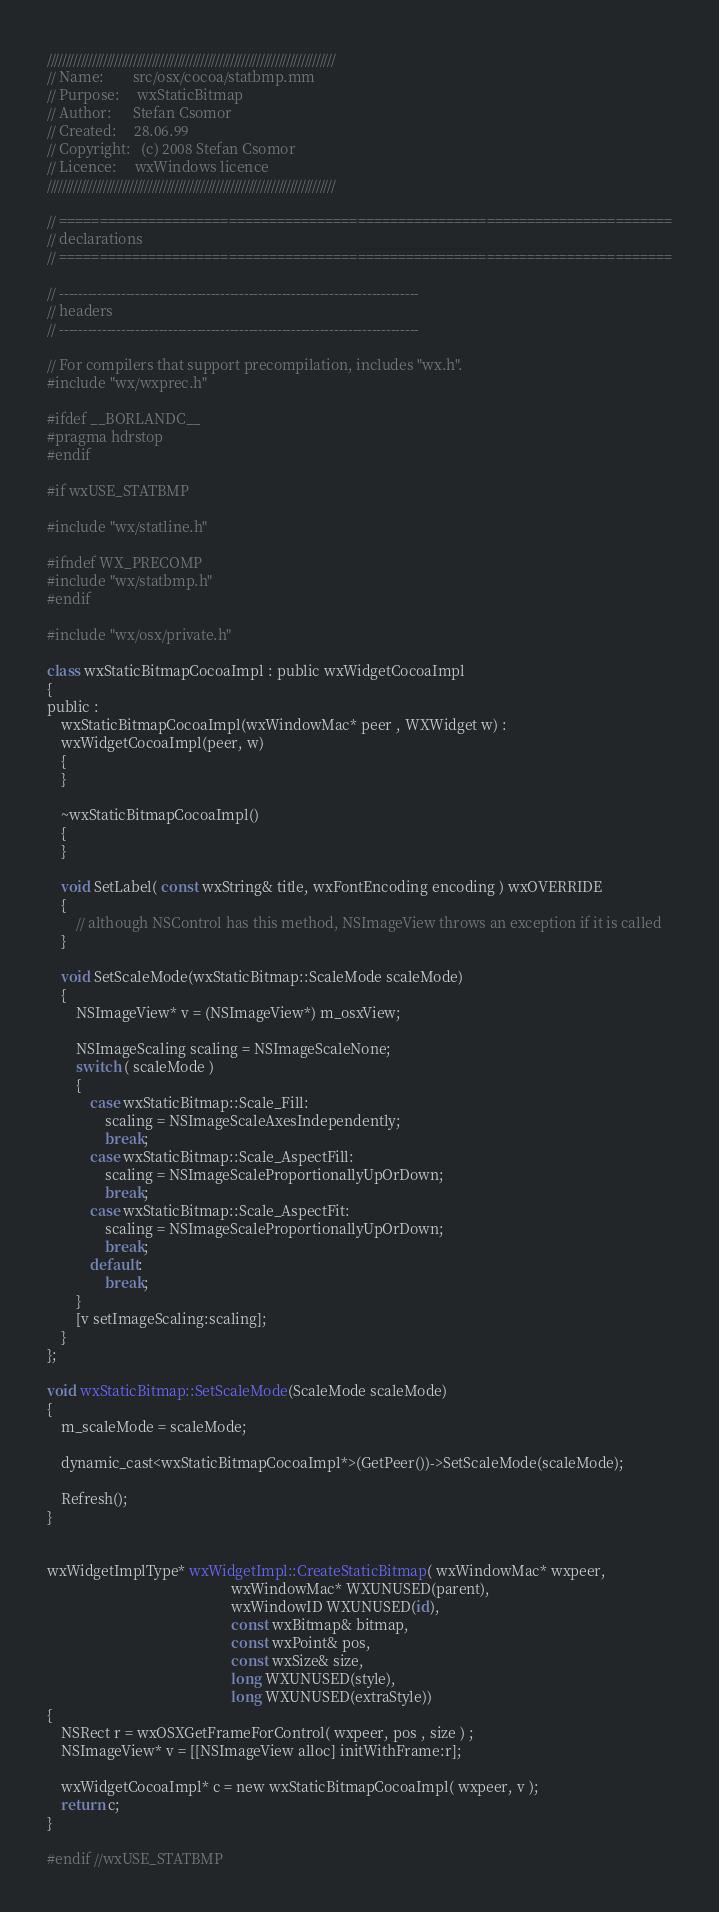Convert code to text. <code><loc_0><loc_0><loc_500><loc_500><_ObjectiveC_>/////////////////////////////////////////////////////////////////////////////
// Name:        src/osx/cocoa/statbmp.mm
// Purpose:     wxStaticBitmap
// Author:      Stefan Csomor
// Created:     28.06.99
// Copyright:   (c) 2008 Stefan Csomor
// Licence:     wxWindows licence
/////////////////////////////////////////////////////////////////////////////

// ============================================================================
// declarations
// ============================================================================

// ----------------------------------------------------------------------------
// headers
// ----------------------------------------------------------------------------

// For compilers that support precompilation, includes "wx.h".
#include "wx/wxprec.h"

#ifdef __BORLANDC__
#pragma hdrstop
#endif

#if wxUSE_STATBMP

#include "wx/statline.h"

#ifndef WX_PRECOMP
#include "wx/statbmp.h"
#endif

#include "wx/osx/private.h"

class wxStaticBitmapCocoaImpl : public wxWidgetCocoaImpl
{
public :
    wxStaticBitmapCocoaImpl(wxWindowMac* peer , WXWidget w) :
    wxWidgetCocoaImpl(peer, w)
    {
    }

    ~wxStaticBitmapCocoaImpl()
    {
    }

	void SetLabel( const wxString& title, wxFontEncoding encoding ) wxOVERRIDE
    {
        // although NSControl has this method, NSImageView throws an exception if it is called
    }

    void SetScaleMode(wxStaticBitmap::ScaleMode scaleMode)
    {
        NSImageView* v = (NSImageView*) m_osxView;

        NSImageScaling scaling = NSImageScaleNone;
        switch ( scaleMode )
        {
            case wxStaticBitmap::Scale_Fill:
                scaling = NSImageScaleAxesIndependently;
                break;
            case wxStaticBitmap::Scale_AspectFill:
                scaling = NSImageScaleProportionallyUpOrDown;
                break;
            case wxStaticBitmap::Scale_AspectFit:
                scaling = NSImageScaleProportionallyUpOrDown;
                break;
            default:
                break;
        }
        [v setImageScaling:scaling];
    }
};

void wxStaticBitmap::SetScaleMode(ScaleMode scaleMode)
{
    m_scaleMode = scaleMode;

    dynamic_cast<wxStaticBitmapCocoaImpl*>(GetPeer())->SetScaleMode(scaleMode);

    Refresh();
}


wxWidgetImplType* wxWidgetImpl::CreateStaticBitmap( wxWindowMac* wxpeer,
                                                   wxWindowMac* WXUNUSED(parent),
                                                   wxWindowID WXUNUSED(id),
                                                   const wxBitmap& bitmap,
                                                   const wxPoint& pos,
                                                   const wxSize& size,
                                                   long WXUNUSED(style),
                                                   long WXUNUSED(extraStyle))
{
    NSRect r = wxOSXGetFrameForControl( wxpeer, pos , size ) ;
    NSImageView* v = [[NSImageView alloc] initWithFrame:r];

    wxWidgetCocoaImpl* c = new wxStaticBitmapCocoaImpl( wxpeer, v );
    return c;
}

#endif //wxUSE_STATBMP
</code> 